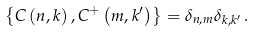Convert formula to latex. <formula><loc_0><loc_0><loc_500><loc_500>\left \{ C \left ( n , k \right ) , C ^ { + } \left ( m , k ^ { \prime } \right ) \right \} = \delta _ { n , m } \delta _ { k , k ^ { \prime } } \, .</formula> 